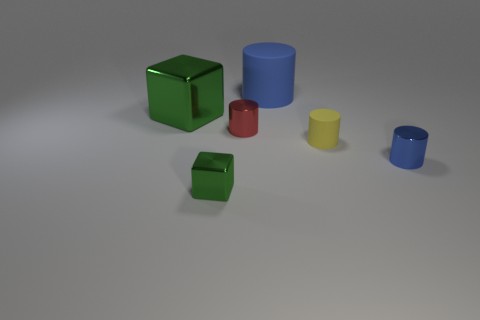What material is the blue thing that is behind the green thing that is left of the small green metal object?
Provide a succinct answer. Rubber. What material is the large object that is left of the tiny green object?
Ensure brevity in your answer.  Metal. What number of small yellow matte objects are the same shape as the large rubber thing?
Keep it short and to the point. 1. Is the color of the tiny block the same as the big shiny object?
Your answer should be very brief. Yes. There is a green thing in front of the green cube that is on the left side of the green shiny block to the right of the big shiny cube; what is it made of?
Provide a short and direct response. Metal. There is a tiny red shiny thing; are there any metal cylinders on the right side of it?
Your answer should be compact. Yes. What shape is the green object that is the same size as the yellow matte object?
Your response must be concise. Cube. Is the material of the tiny blue object the same as the red object?
Make the answer very short. Yes. What number of matte things are either tiny red cylinders or tiny gray balls?
Provide a short and direct response. 0. There is a thing that is the same color as the large rubber cylinder; what is its shape?
Offer a terse response. Cylinder. 